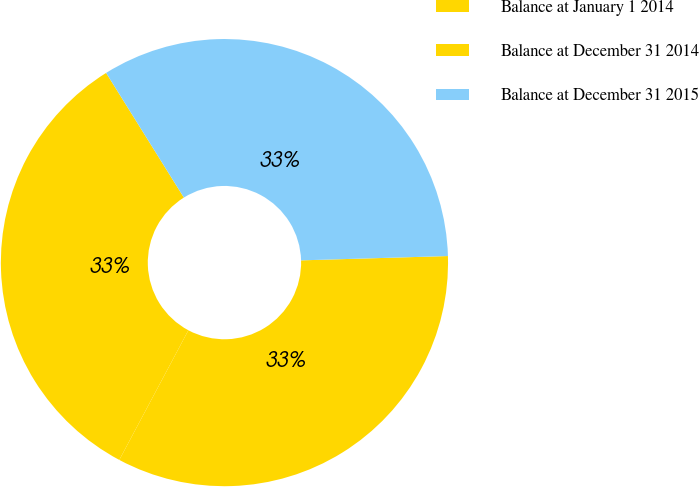<chart> <loc_0><loc_0><loc_500><loc_500><pie_chart><fcel>Balance at January 1 2014<fcel>Balance at December 31 2014<fcel>Balance at December 31 2015<nl><fcel>33.26%<fcel>33.33%<fcel>33.41%<nl></chart> 